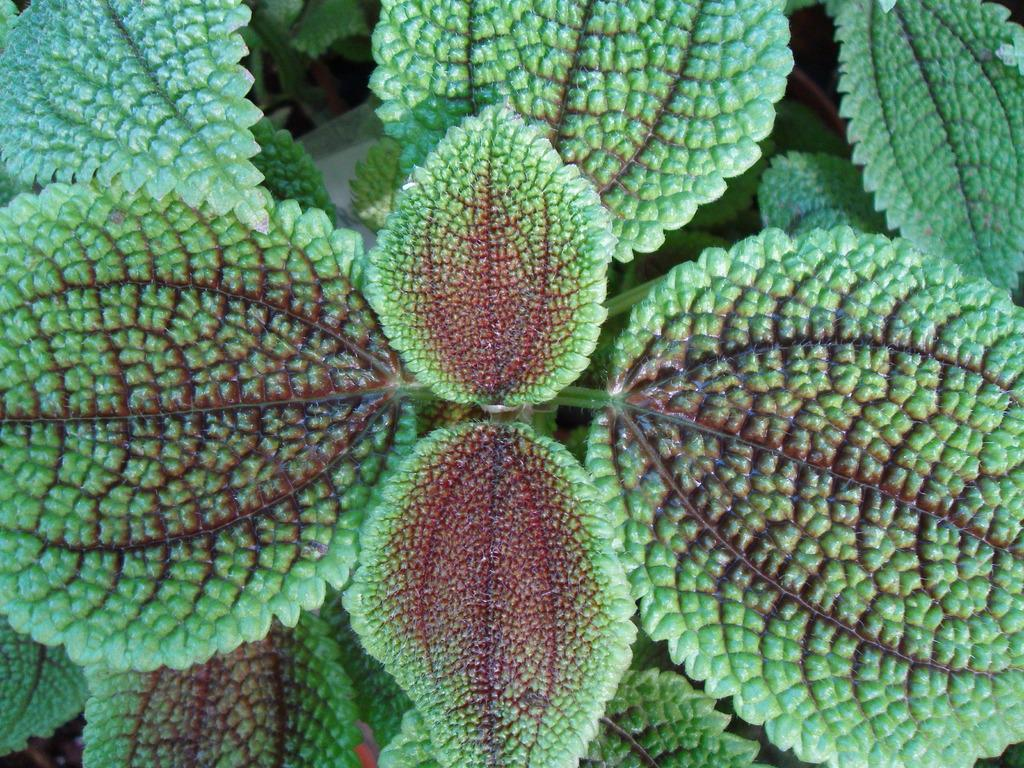What is present in the image? There is a plant in the image. What color are the leaves of the plant? The plant has green leaves. What can be seen in the background of the image? The background of the image includes green leaves. What type of corn can be seen growing in the image? There is no corn present in the image; it features a plant with green leaves. What kind of beam is supporting the plant in the image? There is no beam present in the image; the plant is not shown to be supported by any structure. 